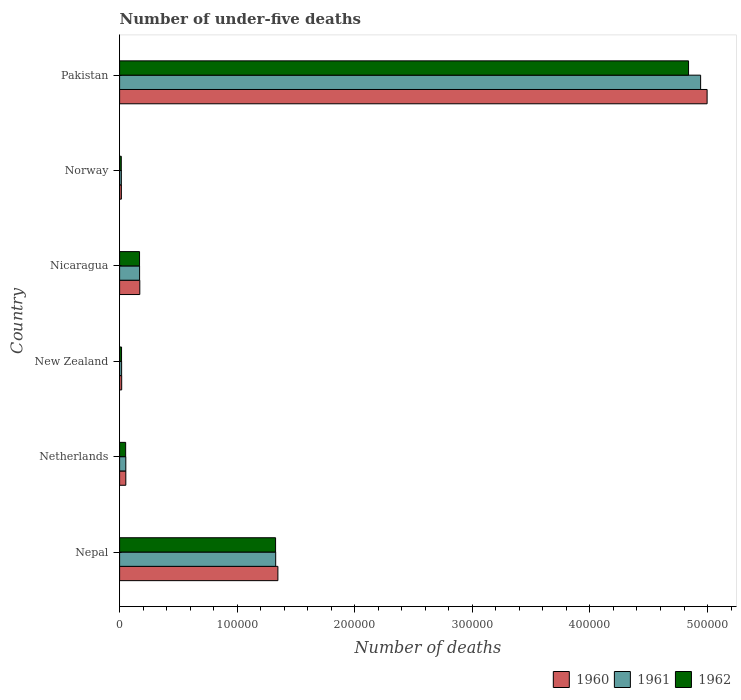How many groups of bars are there?
Give a very brief answer. 6. Are the number of bars on each tick of the Y-axis equal?
Give a very brief answer. Yes. How many bars are there on the 4th tick from the top?
Give a very brief answer. 3. What is the number of under-five deaths in 1962 in Norway?
Make the answer very short. 1422. Across all countries, what is the maximum number of under-five deaths in 1961?
Offer a very short reply. 4.94e+05. Across all countries, what is the minimum number of under-five deaths in 1962?
Your answer should be very brief. 1422. In which country was the number of under-five deaths in 1960 maximum?
Offer a very short reply. Pakistan. In which country was the number of under-five deaths in 1962 minimum?
Keep it short and to the point. Norway. What is the total number of under-five deaths in 1960 in the graph?
Your answer should be very brief. 6.60e+05. What is the difference between the number of under-five deaths in 1960 in New Zealand and that in Nicaragua?
Make the answer very short. -1.54e+04. What is the difference between the number of under-five deaths in 1962 in Nicaragua and the number of under-five deaths in 1960 in Nepal?
Your answer should be very brief. -1.18e+05. What is the average number of under-five deaths in 1961 per country?
Provide a short and direct response. 1.09e+05. In how many countries, is the number of under-five deaths in 1962 greater than 340000 ?
Provide a short and direct response. 1. What is the ratio of the number of under-five deaths in 1961 in Norway to that in Pakistan?
Keep it short and to the point. 0. Is the difference between the number of under-five deaths in 1961 in Nepal and Norway greater than the difference between the number of under-five deaths in 1962 in Nepal and Norway?
Provide a short and direct response. Yes. What is the difference between the highest and the second highest number of under-five deaths in 1960?
Your response must be concise. 3.65e+05. What is the difference between the highest and the lowest number of under-five deaths in 1961?
Keep it short and to the point. 4.93e+05. Is the sum of the number of under-five deaths in 1961 in New Zealand and Nicaragua greater than the maximum number of under-five deaths in 1962 across all countries?
Provide a short and direct response. No. What does the 1st bar from the bottom in Norway represents?
Give a very brief answer. 1960. Is it the case that in every country, the sum of the number of under-five deaths in 1960 and number of under-five deaths in 1962 is greater than the number of under-five deaths in 1961?
Ensure brevity in your answer.  Yes. Are all the bars in the graph horizontal?
Provide a short and direct response. Yes. How many countries are there in the graph?
Your response must be concise. 6. What is the difference between two consecutive major ticks on the X-axis?
Provide a short and direct response. 1.00e+05. Does the graph contain any zero values?
Keep it short and to the point. No. Where does the legend appear in the graph?
Provide a succinct answer. Bottom right. How many legend labels are there?
Provide a short and direct response. 3. What is the title of the graph?
Give a very brief answer. Number of under-five deaths. What is the label or title of the X-axis?
Your answer should be compact. Number of deaths. What is the Number of deaths in 1960 in Nepal?
Provide a short and direct response. 1.35e+05. What is the Number of deaths in 1961 in Nepal?
Make the answer very short. 1.33e+05. What is the Number of deaths in 1962 in Nepal?
Offer a very short reply. 1.33e+05. What is the Number of deaths of 1960 in Netherlands?
Your answer should be compact. 5281. What is the Number of deaths of 1961 in Netherlands?
Offer a very short reply. 5288. What is the Number of deaths of 1962 in Netherlands?
Provide a short and direct response. 5152. What is the Number of deaths of 1960 in New Zealand?
Offer a very short reply. 1768. What is the Number of deaths in 1961 in New Zealand?
Give a very brief answer. 1719. What is the Number of deaths in 1962 in New Zealand?
Your response must be concise. 1649. What is the Number of deaths in 1960 in Nicaragua?
Provide a short and direct response. 1.72e+04. What is the Number of deaths of 1961 in Nicaragua?
Keep it short and to the point. 1.70e+04. What is the Number of deaths in 1962 in Nicaragua?
Your response must be concise. 1.70e+04. What is the Number of deaths of 1960 in Norway?
Ensure brevity in your answer.  1503. What is the Number of deaths in 1961 in Norway?
Make the answer very short. 1480. What is the Number of deaths of 1962 in Norway?
Offer a very short reply. 1422. What is the Number of deaths in 1960 in Pakistan?
Your answer should be compact. 5.00e+05. What is the Number of deaths of 1961 in Pakistan?
Keep it short and to the point. 4.94e+05. What is the Number of deaths in 1962 in Pakistan?
Offer a terse response. 4.84e+05. Across all countries, what is the maximum Number of deaths in 1960?
Give a very brief answer. 5.00e+05. Across all countries, what is the maximum Number of deaths of 1961?
Give a very brief answer. 4.94e+05. Across all countries, what is the maximum Number of deaths in 1962?
Ensure brevity in your answer.  4.84e+05. Across all countries, what is the minimum Number of deaths in 1960?
Make the answer very short. 1503. Across all countries, what is the minimum Number of deaths of 1961?
Make the answer very short. 1480. Across all countries, what is the minimum Number of deaths in 1962?
Ensure brevity in your answer.  1422. What is the total Number of deaths of 1960 in the graph?
Your response must be concise. 6.60e+05. What is the total Number of deaths in 1961 in the graph?
Provide a succinct answer. 6.52e+05. What is the total Number of deaths in 1962 in the graph?
Offer a very short reply. 6.42e+05. What is the difference between the Number of deaths in 1960 in Nepal and that in Netherlands?
Keep it short and to the point. 1.29e+05. What is the difference between the Number of deaths of 1961 in Nepal and that in Netherlands?
Your answer should be very brief. 1.27e+05. What is the difference between the Number of deaths of 1962 in Nepal and that in Netherlands?
Your response must be concise. 1.27e+05. What is the difference between the Number of deaths in 1960 in Nepal and that in New Zealand?
Offer a terse response. 1.33e+05. What is the difference between the Number of deaths in 1961 in Nepal and that in New Zealand?
Ensure brevity in your answer.  1.31e+05. What is the difference between the Number of deaths of 1962 in Nepal and that in New Zealand?
Offer a terse response. 1.31e+05. What is the difference between the Number of deaths in 1960 in Nepal and that in Nicaragua?
Provide a short and direct response. 1.17e+05. What is the difference between the Number of deaths in 1961 in Nepal and that in Nicaragua?
Ensure brevity in your answer.  1.16e+05. What is the difference between the Number of deaths of 1962 in Nepal and that in Nicaragua?
Make the answer very short. 1.16e+05. What is the difference between the Number of deaths of 1960 in Nepal and that in Norway?
Make the answer very short. 1.33e+05. What is the difference between the Number of deaths of 1961 in Nepal and that in Norway?
Offer a terse response. 1.31e+05. What is the difference between the Number of deaths in 1962 in Nepal and that in Norway?
Provide a short and direct response. 1.31e+05. What is the difference between the Number of deaths in 1960 in Nepal and that in Pakistan?
Ensure brevity in your answer.  -3.65e+05. What is the difference between the Number of deaths in 1961 in Nepal and that in Pakistan?
Make the answer very short. -3.61e+05. What is the difference between the Number of deaths in 1962 in Nepal and that in Pakistan?
Ensure brevity in your answer.  -3.51e+05. What is the difference between the Number of deaths of 1960 in Netherlands and that in New Zealand?
Offer a very short reply. 3513. What is the difference between the Number of deaths of 1961 in Netherlands and that in New Zealand?
Provide a short and direct response. 3569. What is the difference between the Number of deaths in 1962 in Netherlands and that in New Zealand?
Your answer should be very brief. 3503. What is the difference between the Number of deaths in 1960 in Netherlands and that in Nicaragua?
Provide a short and direct response. -1.19e+04. What is the difference between the Number of deaths of 1961 in Netherlands and that in Nicaragua?
Offer a terse response. -1.17e+04. What is the difference between the Number of deaths in 1962 in Netherlands and that in Nicaragua?
Give a very brief answer. -1.18e+04. What is the difference between the Number of deaths of 1960 in Netherlands and that in Norway?
Offer a very short reply. 3778. What is the difference between the Number of deaths of 1961 in Netherlands and that in Norway?
Make the answer very short. 3808. What is the difference between the Number of deaths in 1962 in Netherlands and that in Norway?
Provide a succinct answer. 3730. What is the difference between the Number of deaths of 1960 in Netherlands and that in Pakistan?
Offer a terse response. -4.94e+05. What is the difference between the Number of deaths in 1961 in Netherlands and that in Pakistan?
Provide a succinct answer. -4.89e+05. What is the difference between the Number of deaths of 1962 in Netherlands and that in Pakistan?
Your answer should be very brief. -4.79e+05. What is the difference between the Number of deaths in 1960 in New Zealand and that in Nicaragua?
Give a very brief answer. -1.54e+04. What is the difference between the Number of deaths in 1961 in New Zealand and that in Nicaragua?
Make the answer very short. -1.53e+04. What is the difference between the Number of deaths in 1962 in New Zealand and that in Nicaragua?
Ensure brevity in your answer.  -1.53e+04. What is the difference between the Number of deaths of 1960 in New Zealand and that in Norway?
Provide a short and direct response. 265. What is the difference between the Number of deaths in 1961 in New Zealand and that in Norway?
Give a very brief answer. 239. What is the difference between the Number of deaths in 1962 in New Zealand and that in Norway?
Make the answer very short. 227. What is the difference between the Number of deaths of 1960 in New Zealand and that in Pakistan?
Keep it short and to the point. -4.98e+05. What is the difference between the Number of deaths of 1961 in New Zealand and that in Pakistan?
Give a very brief answer. -4.92e+05. What is the difference between the Number of deaths in 1962 in New Zealand and that in Pakistan?
Give a very brief answer. -4.82e+05. What is the difference between the Number of deaths in 1960 in Nicaragua and that in Norway?
Make the answer very short. 1.57e+04. What is the difference between the Number of deaths in 1961 in Nicaragua and that in Norway?
Make the answer very short. 1.55e+04. What is the difference between the Number of deaths of 1962 in Nicaragua and that in Norway?
Your response must be concise. 1.55e+04. What is the difference between the Number of deaths in 1960 in Nicaragua and that in Pakistan?
Your response must be concise. -4.82e+05. What is the difference between the Number of deaths of 1961 in Nicaragua and that in Pakistan?
Your answer should be compact. -4.77e+05. What is the difference between the Number of deaths in 1962 in Nicaragua and that in Pakistan?
Offer a terse response. -4.67e+05. What is the difference between the Number of deaths of 1960 in Norway and that in Pakistan?
Keep it short and to the point. -4.98e+05. What is the difference between the Number of deaths in 1961 in Norway and that in Pakistan?
Offer a very short reply. -4.93e+05. What is the difference between the Number of deaths in 1962 in Norway and that in Pakistan?
Make the answer very short. -4.82e+05. What is the difference between the Number of deaths of 1960 in Nepal and the Number of deaths of 1961 in Netherlands?
Your answer should be compact. 1.29e+05. What is the difference between the Number of deaths in 1960 in Nepal and the Number of deaths in 1962 in Netherlands?
Provide a short and direct response. 1.29e+05. What is the difference between the Number of deaths of 1961 in Nepal and the Number of deaths of 1962 in Netherlands?
Give a very brief answer. 1.28e+05. What is the difference between the Number of deaths in 1960 in Nepal and the Number of deaths in 1961 in New Zealand?
Offer a terse response. 1.33e+05. What is the difference between the Number of deaths of 1960 in Nepal and the Number of deaths of 1962 in New Zealand?
Make the answer very short. 1.33e+05. What is the difference between the Number of deaths in 1961 in Nepal and the Number of deaths in 1962 in New Zealand?
Keep it short and to the point. 1.31e+05. What is the difference between the Number of deaths of 1960 in Nepal and the Number of deaths of 1961 in Nicaragua?
Your answer should be very brief. 1.18e+05. What is the difference between the Number of deaths of 1960 in Nepal and the Number of deaths of 1962 in Nicaragua?
Provide a short and direct response. 1.18e+05. What is the difference between the Number of deaths of 1961 in Nepal and the Number of deaths of 1962 in Nicaragua?
Your response must be concise. 1.16e+05. What is the difference between the Number of deaths of 1960 in Nepal and the Number of deaths of 1961 in Norway?
Provide a succinct answer. 1.33e+05. What is the difference between the Number of deaths of 1960 in Nepal and the Number of deaths of 1962 in Norway?
Ensure brevity in your answer.  1.33e+05. What is the difference between the Number of deaths in 1961 in Nepal and the Number of deaths in 1962 in Norway?
Provide a succinct answer. 1.31e+05. What is the difference between the Number of deaths in 1960 in Nepal and the Number of deaths in 1961 in Pakistan?
Provide a succinct answer. -3.60e+05. What is the difference between the Number of deaths of 1960 in Nepal and the Number of deaths of 1962 in Pakistan?
Keep it short and to the point. -3.49e+05. What is the difference between the Number of deaths of 1961 in Nepal and the Number of deaths of 1962 in Pakistan?
Your response must be concise. -3.51e+05. What is the difference between the Number of deaths in 1960 in Netherlands and the Number of deaths in 1961 in New Zealand?
Keep it short and to the point. 3562. What is the difference between the Number of deaths of 1960 in Netherlands and the Number of deaths of 1962 in New Zealand?
Provide a succinct answer. 3632. What is the difference between the Number of deaths in 1961 in Netherlands and the Number of deaths in 1962 in New Zealand?
Offer a very short reply. 3639. What is the difference between the Number of deaths of 1960 in Netherlands and the Number of deaths of 1961 in Nicaragua?
Give a very brief answer. -1.17e+04. What is the difference between the Number of deaths of 1960 in Netherlands and the Number of deaths of 1962 in Nicaragua?
Ensure brevity in your answer.  -1.17e+04. What is the difference between the Number of deaths of 1961 in Netherlands and the Number of deaths of 1962 in Nicaragua?
Provide a short and direct response. -1.17e+04. What is the difference between the Number of deaths of 1960 in Netherlands and the Number of deaths of 1961 in Norway?
Offer a terse response. 3801. What is the difference between the Number of deaths of 1960 in Netherlands and the Number of deaths of 1962 in Norway?
Make the answer very short. 3859. What is the difference between the Number of deaths in 1961 in Netherlands and the Number of deaths in 1962 in Norway?
Offer a terse response. 3866. What is the difference between the Number of deaths of 1960 in Netherlands and the Number of deaths of 1961 in Pakistan?
Offer a very short reply. -4.89e+05. What is the difference between the Number of deaths of 1960 in Netherlands and the Number of deaths of 1962 in Pakistan?
Your answer should be very brief. -4.79e+05. What is the difference between the Number of deaths in 1961 in Netherlands and the Number of deaths in 1962 in Pakistan?
Provide a short and direct response. -4.79e+05. What is the difference between the Number of deaths in 1960 in New Zealand and the Number of deaths in 1961 in Nicaragua?
Your answer should be compact. -1.52e+04. What is the difference between the Number of deaths of 1960 in New Zealand and the Number of deaths of 1962 in Nicaragua?
Keep it short and to the point. -1.52e+04. What is the difference between the Number of deaths in 1961 in New Zealand and the Number of deaths in 1962 in Nicaragua?
Offer a terse response. -1.52e+04. What is the difference between the Number of deaths in 1960 in New Zealand and the Number of deaths in 1961 in Norway?
Your response must be concise. 288. What is the difference between the Number of deaths of 1960 in New Zealand and the Number of deaths of 1962 in Norway?
Offer a terse response. 346. What is the difference between the Number of deaths of 1961 in New Zealand and the Number of deaths of 1962 in Norway?
Offer a very short reply. 297. What is the difference between the Number of deaths in 1960 in New Zealand and the Number of deaths in 1961 in Pakistan?
Make the answer very short. -4.92e+05. What is the difference between the Number of deaths of 1960 in New Zealand and the Number of deaths of 1962 in Pakistan?
Provide a succinct answer. -4.82e+05. What is the difference between the Number of deaths in 1961 in New Zealand and the Number of deaths in 1962 in Pakistan?
Offer a very short reply. -4.82e+05. What is the difference between the Number of deaths of 1960 in Nicaragua and the Number of deaths of 1961 in Norway?
Your answer should be compact. 1.57e+04. What is the difference between the Number of deaths of 1960 in Nicaragua and the Number of deaths of 1962 in Norway?
Give a very brief answer. 1.57e+04. What is the difference between the Number of deaths in 1961 in Nicaragua and the Number of deaths in 1962 in Norway?
Your answer should be compact. 1.56e+04. What is the difference between the Number of deaths in 1960 in Nicaragua and the Number of deaths in 1961 in Pakistan?
Offer a very short reply. -4.77e+05. What is the difference between the Number of deaths in 1960 in Nicaragua and the Number of deaths in 1962 in Pakistan?
Your answer should be very brief. -4.67e+05. What is the difference between the Number of deaths of 1961 in Nicaragua and the Number of deaths of 1962 in Pakistan?
Your response must be concise. -4.67e+05. What is the difference between the Number of deaths of 1960 in Norway and the Number of deaths of 1961 in Pakistan?
Provide a succinct answer. -4.93e+05. What is the difference between the Number of deaths in 1960 in Norway and the Number of deaths in 1962 in Pakistan?
Your response must be concise. -4.82e+05. What is the difference between the Number of deaths of 1961 in Norway and the Number of deaths of 1962 in Pakistan?
Keep it short and to the point. -4.82e+05. What is the average Number of deaths in 1960 per country?
Your answer should be compact. 1.10e+05. What is the average Number of deaths in 1961 per country?
Keep it short and to the point. 1.09e+05. What is the average Number of deaths of 1962 per country?
Ensure brevity in your answer.  1.07e+05. What is the difference between the Number of deaths of 1960 and Number of deaths of 1961 in Nepal?
Offer a terse response. 1868. What is the difference between the Number of deaths of 1960 and Number of deaths of 1962 in Nepal?
Your response must be concise. 1967. What is the difference between the Number of deaths of 1960 and Number of deaths of 1962 in Netherlands?
Your response must be concise. 129. What is the difference between the Number of deaths in 1961 and Number of deaths in 1962 in Netherlands?
Ensure brevity in your answer.  136. What is the difference between the Number of deaths in 1960 and Number of deaths in 1961 in New Zealand?
Ensure brevity in your answer.  49. What is the difference between the Number of deaths of 1960 and Number of deaths of 1962 in New Zealand?
Give a very brief answer. 119. What is the difference between the Number of deaths in 1960 and Number of deaths in 1961 in Nicaragua?
Offer a terse response. 167. What is the difference between the Number of deaths of 1960 and Number of deaths of 1962 in Nicaragua?
Provide a succinct answer. 207. What is the difference between the Number of deaths in 1961 and Number of deaths in 1962 in Norway?
Your answer should be compact. 58. What is the difference between the Number of deaths in 1960 and Number of deaths in 1961 in Pakistan?
Offer a terse response. 5515. What is the difference between the Number of deaths of 1960 and Number of deaths of 1962 in Pakistan?
Provide a succinct answer. 1.58e+04. What is the difference between the Number of deaths in 1961 and Number of deaths in 1962 in Pakistan?
Ensure brevity in your answer.  1.03e+04. What is the ratio of the Number of deaths in 1960 in Nepal to that in Netherlands?
Offer a very short reply. 25.49. What is the ratio of the Number of deaths in 1961 in Nepal to that in Netherlands?
Give a very brief answer. 25.1. What is the ratio of the Number of deaths in 1962 in Nepal to that in Netherlands?
Offer a very short reply. 25.75. What is the ratio of the Number of deaths of 1960 in Nepal to that in New Zealand?
Provide a short and direct response. 76.14. What is the ratio of the Number of deaths in 1961 in Nepal to that in New Zealand?
Keep it short and to the point. 77.22. What is the ratio of the Number of deaths of 1962 in Nepal to that in New Zealand?
Your answer should be compact. 80.44. What is the ratio of the Number of deaths of 1960 in Nepal to that in Nicaragua?
Offer a very short reply. 7.84. What is the ratio of the Number of deaths in 1961 in Nepal to that in Nicaragua?
Ensure brevity in your answer.  7.81. What is the ratio of the Number of deaths of 1962 in Nepal to that in Nicaragua?
Give a very brief answer. 7.82. What is the ratio of the Number of deaths of 1960 in Nepal to that in Norway?
Offer a terse response. 89.56. What is the ratio of the Number of deaths of 1961 in Nepal to that in Norway?
Provide a succinct answer. 89.69. What is the ratio of the Number of deaths in 1962 in Nepal to that in Norway?
Offer a very short reply. 93.28. What is the ratio of the Number of deaths of 1960 in Nepal to that in Pakistan?
Provide a succinct answer. 0.27. What is the ratio of the Number of deaths in 1961 in Nepal to that in Pakistan?
Offer a terse response. 0.27. What is the ratio of the Number of deaths of 1962 in Nepal to that in Pakistan?
Your answer should be compact. 0.27. What is the ratio of the Number of deaths in 1960 in Netherlands to that in New Zealand?
Provide a succinct answer. 2.99. What is the ratio of the Number of deaths of 1961 in Netherlands to that in New Zealand?
Provide a short and direct response. 3.08. What is the ratio of the Number of deaths of 1962 in Netherlands to that in New Zealand?
Provide a succinct answer. 3.12. What is the ratio of the Number of deaths in 1960 in Netherlands to that in Nicaragua?
Offer a terse response. 0.31. What is the ratio of the Number of deaths in 1961 in Netherlands to that in Nicaragua?
Provide a succinct answer. 0.31. What is the ratio of the Number of deaths of 1962 in Netherlands to that in Nicaragua?
Provide a succinct answer. 0.3. What is the ratio of the Number of deaths of 1960 in Netherlands to that in Norway?
Keep it short and to the point. 3.51. What is the ratio of the Number of deaths in 1961 in Netherlands to that in Norway?
Your answer should be very brief. 3.57. What is the ratio of the Number of deaths in 1962 in Netherlands to that in Norway?
Offer a terse response. 3.62. What is the ratio of the Number of deaths in 1960 in Netherlands to that in Pakistan?
Your answer should be very brief. 0.01. What is the ratio of the Number of deaths of 1961 in Netherlands to that in Pakistan?
Your answer should be compact. 0.01. What is the ratio of the Number of deaths of 1962 in Netherlands to that in Pakistan?
Ensure brevity in your answer.  0.01. What is the ratio of the Number of deaths in 1960 in New Zealand to that in Nicaragua?
Your answer should be compact. 0.1. What is the ratio of the Number of deaths of 1961 in New Zealand to that in Nicaragua?
Give a very brief answer. 0.1. What is the ratio of the Number of deaths of 1962 in New Zealand to that in Nicaragua?
Offer a terse response. 0.1. What is the ratio of the Number of deaths in 1960 in New Zealand to that in Norway?
Make the answer very short. 1.18. What is the ratio of the Number of deaths of 1961 in New Zealand to that in Norway?
Make the answer very short. 1.16. What is the ratio of the Number of deaths of 1962 in New Zealand to that in Norway?
Your answer should be compact. 1.16. What is the ratio of the Number of deaths of 1960 in New Zealand to that in Pakistan?
Your answer should be very brief. 0. What is the ratio of the Number of deaths in 1961 in New Zealand to that in Pakistan?
Your answer should be compact. 0. What is the ratio of the Number of deaths in 1962 in New Zealand to that in Pakistan?
Offer a terse response. 0. What is the ratio of the Number of deaths in 1960 in Nicaragua to that in Norway?
Your response must be concise. 11.42. What is the ratio of the Number of deaths in 1961 in Nicaragua to that in Norway?
Make the answer very short. 11.49. What is the ratio of the Number of deaths in 1962 in Nicaragua to that in Norway?
Your answer should be very brief. 11.93. What is the ratio of the Number of deaths in 1960 in Nicaragua to that in Pakistan?
Your response must be concise. 0.03. What is the ratio of the Number of deaths in 1961 in Nicaragua to that in Pakistan?
Give a very brief answer. 0.03. What is the ratio of the Number of deaths in 1962 in Nicaragua to that in Pakistan?
Ensure brevity in your answer.  0.04. What is the ratio of the Number of deaths in 1960 in Norway to that in Pakistan?
Provide a short and direct response. 0. What is the ratio of the Number of deaths in 1961 in Norway to that in Pakistan?
Offer a terse response. 0. What is the ratio of the Number of deaths in 1962 in Norway to that in Pakistan?
Offer a very short reply. 0. What is the difference between the highest and the second highest Number of deaths in 1960?
Provide a succinct answer. 3.65e+05. What is the difference between the highest and the second highest Number of deaths in 1961?
Ensure brevity in your answer.  3.61e+05. What is the difference between the highest and the second highest Number of deaths in 1962?
Offer a very short reply. 3.51e+05. What is the difference between the highest and the lowest Number of deaths of 1960?
Offer a terse response. 4.98e+05. What is the difference between the highest and the lowest Number of deaths of 1961?
Make the answer very short. 4.93e+05. What is the difference between the highest and the lowest Number of deaths of 1962?
Your answer should be very brief. 4.82e+05. 